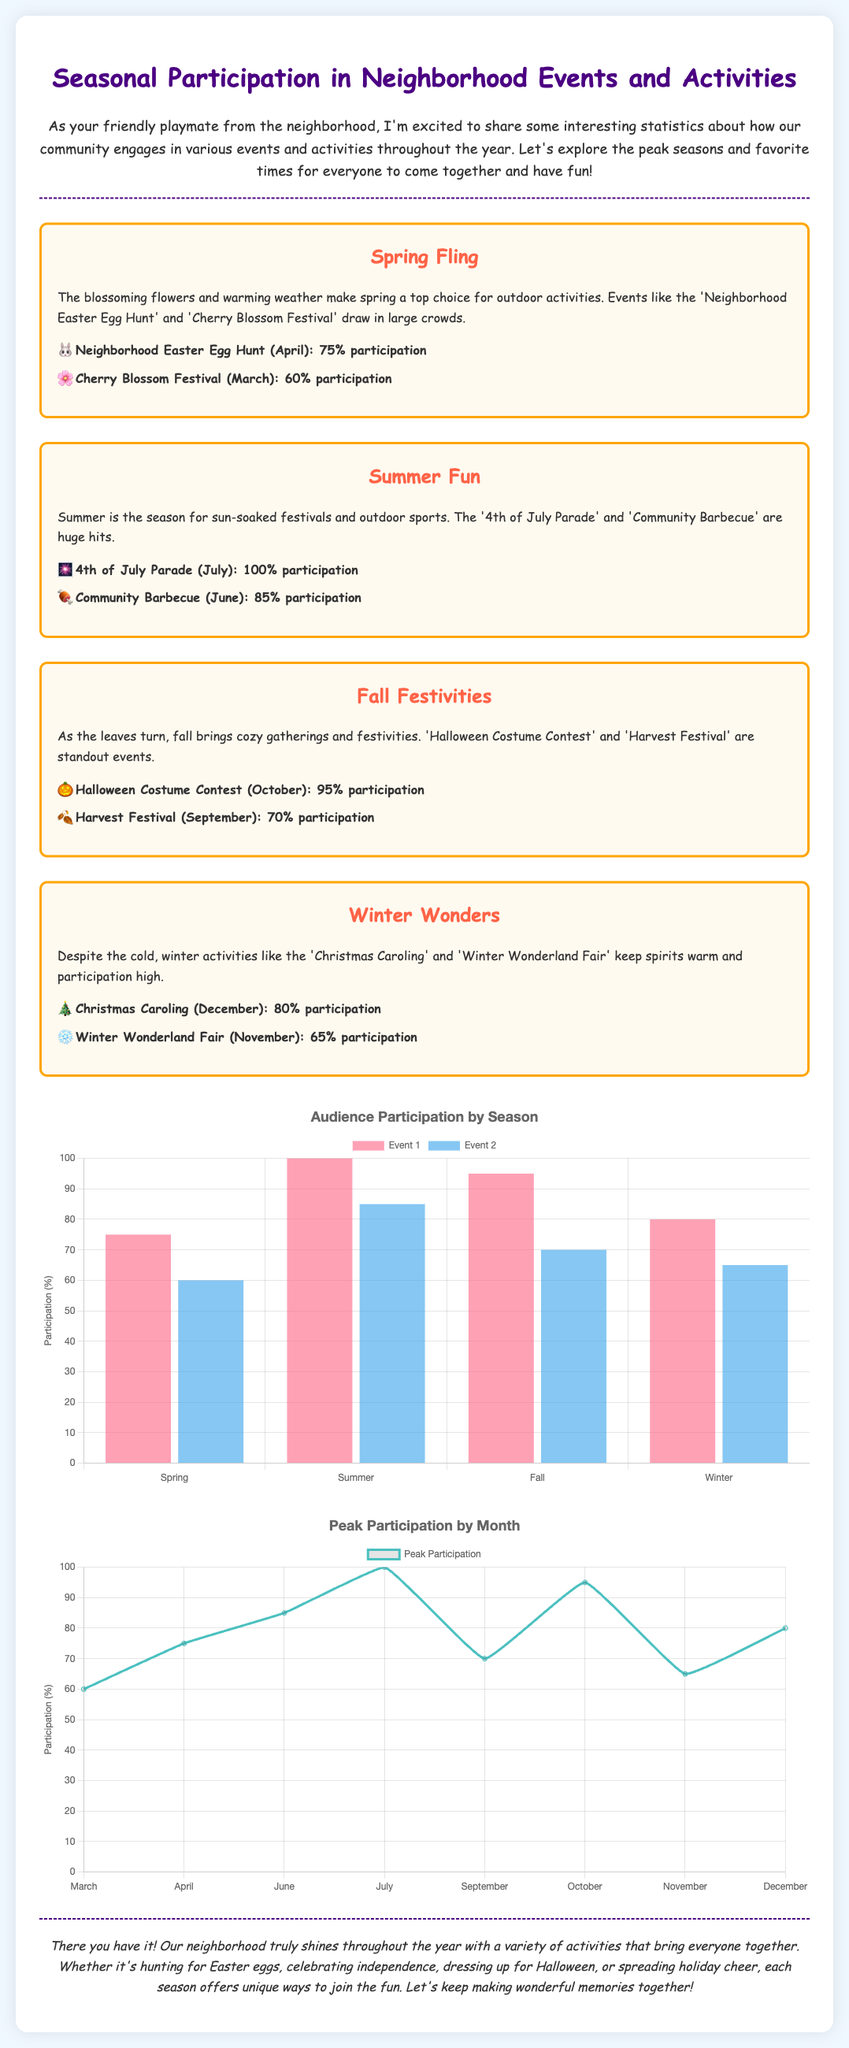What event had the highest participation? The event with the highest participation is the '4th of July Parade' with 100%.
Answer: 100% Which season has the Cherry Blossom Festival? The Cherry Blossom Festival takes place in Spring.
Answer: Spring What percentage of participation was recorded for the Halloween Costume Contest? The Halloween Costume Contest had a participation rate of 95%.
Answer: 95% In which month does the Community Barbecue occur? The Community Barbecue occurs in June.
Answer: June How many events are listed for Winter? There are two events listed for Winter.
Answer: Two Which season shows the peak participation for events? Summer shows the peak participation for events with 100%.
Answer: Summer What is the participation percentage for the Harvest Festival? The participation percentage for the Harvest Festival is 70%.
Answer: 70% What color represents the line chart for peak participation by month? The color that represents the line chart for peak participation is rgb(75, 192, 192).
Answer: rgb(75, 192, 192) 